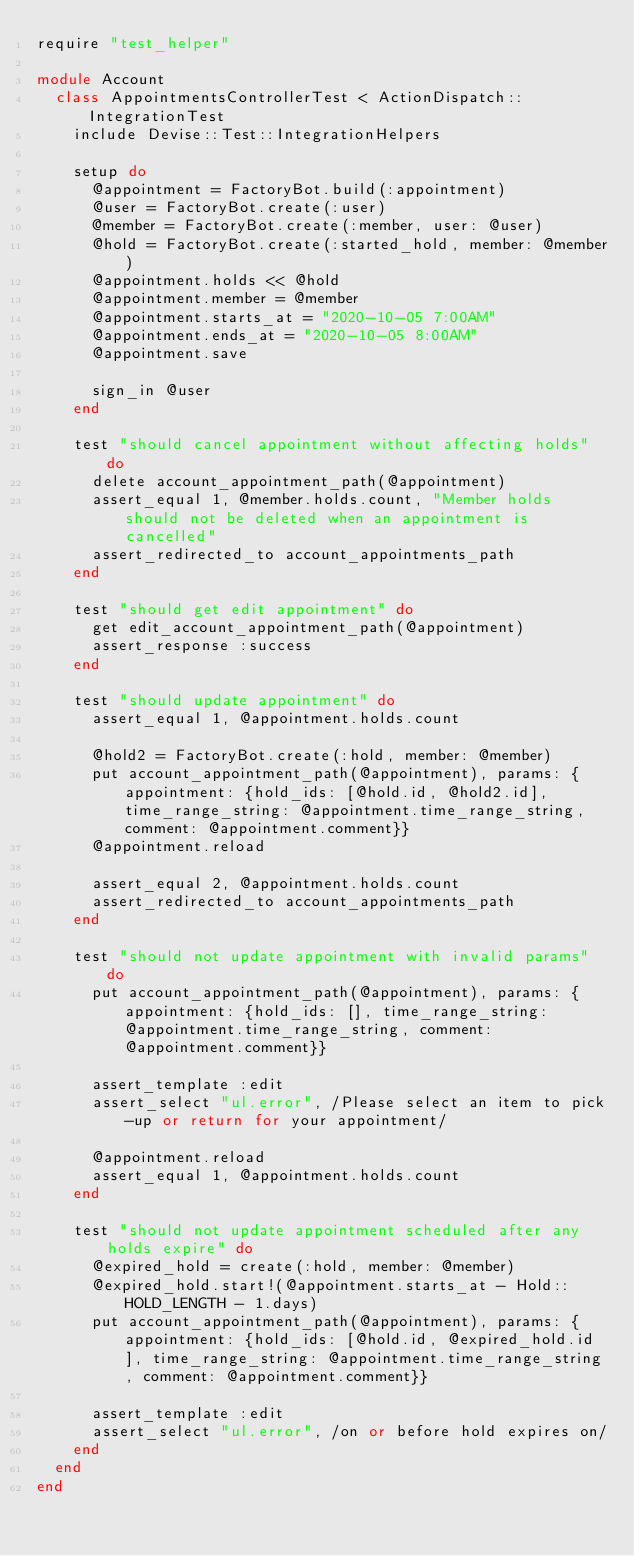<code> <loc_0><loc_0><loc_500><loc_500><_Ruby_>require "test_helper"

module Account
  class AppointmentsControllerTest < ActionDispatch::IntegrationTest
    include Devise::Test::IntegrationHelpers

    setup do
      @appointment = FactoryBot.build(:appointment)
      @user = FactoryBot.create(:user)
      @member = FactoryBot.create(:member, user: @user)
      @hold = FactoryBot.create(:started_hold, member: @member)
      @appointment.holds << @hold
      @appointment.member = @member
      @appointment.starts_at = "2020-10-05 7:00AM"
      @appointment.ends_at = "2020-10-05 8:00AM"
      @appointment.save

      sign_in @user
    end

    test "should cancel appointment without affecting holds" do
      delete account_appointment_path(@appointment)
      assert_equal 1, @member.holds.count, "Member holds should not be deleted when an appointment is cancelled"
      assert_redirected_to account_appointments_path
    end

    test "should get edit appointment" do
      get edit_account_appointment_path(@appointment)
      assert_response :success
    end

    test "should update appointment" do
      assert_equal 1, @appointment.holds.count

      @hold2 = FactoryBot.create(:hold, member: @member)
      put account_appointment_path(@appointment), params: {appointment: {hold_ids: [@hold.id, @hold2.id], time_range_string: @appointment.time_range_string, comment: @appointment.comment}}
      @appointment.reload

      assert_equal 2, @appointment.holds.count
      assert_redirected_to account_appointments_path
    end

    test "should not update appointment with invalid params" do
      put account_appointment_path(@appointment), params: {appointment: {hold_ids: [], time_range_string: @appointment.time_range_string, comment: @appointment.comment}}

      assert_template :edit
      assert_select "ul.error", /Please select an item to pick-up or return for your appointment/

      @appointment.reload
      assert_equal 1, @appointment.holds.count
    end

    test "should not update appointment scheduled after any holds expire" do
      @expired_hold = create(:hold, member: @member)
      @expired_hold.start!(@appointment.starts_at - Hold::HOLD_LENGTH - 1.days)
      put account_appointment_path(@appointment), params: {appointment: {hold_ids: [@hold.id, @expired_hold.id], time_range_string: @appointment.time_range_string, comment: @appointment.comment}}

      assert_template :edit
      assert_select "ul.error", /on or before hold expires on/
    end
  end
end
</code> 